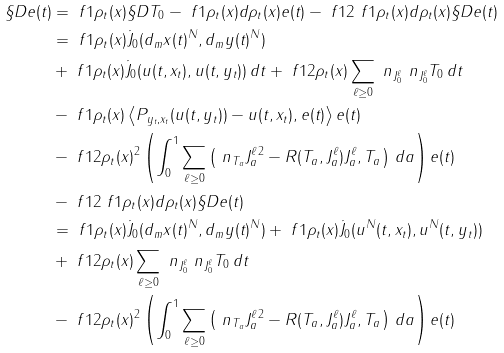<formula> <loc_0><loc_0><loc_500><loc_500>\S D e ( t ) & = \ f 1 { \rho _ { t } ( x ) } \S D T _ { 0 } - \ f 1 { \rho _ { t } ( x ) } d \rho _ { t } ( x ) e ( t ) - \ f 1 2 \ f 1 { \rho _ { t } ( x ) } d \rho _ { t } ( x ) \S D e ( t ) \\ & = \ f 1 { \rho _ { t } ( x ) } \dot { J } _ { 0 } ( d _ { m } x ( t ) ^ { N } , d _ { m } y ( t ) ^ { N } ) \\ & + \ f 1 { \rho _ { t } ( x ) } \dot { J } _ { 0 } ( u ( t , x _ { t } ) , u ( t , y _ { t } ) ) \, d t + \ f 1 { 2 \rho _ { t } ( x ) } \sum _ { \ell \geq 0 } \ n _ { J _ { 0 } ^ { \ell } } \ n _ { J _ { 0 } ^ { \ell } } T _ { 0 } \, d t \\ & - \ f 1 { \rho _ { t } ( x ) } \left \langle P _ { y _ { t } , x _ { t } } ( u ( t , y _ { t } ) ) - u ( t , x _ { t } ) , e ( t ) \right \rangle e ( t ) \\ & - \ f 1 { 2 \rho _ { t } ( x ) ^ { 2 } } \left ( \int _ { 0 } ^ { 1 } \sum _ { \ell \geq 0 } \left ( \| \ n _ { T _ { a } } J _ { a } ^ { \ell } \| ^ { 2 } - R ( T _ { a } , J _ { a } ^ { \ell } ) J _ { a } ^ { \ell } , T _ { a } \right ) \, d a \right ) e ( t ) \\ & - \ f 1 2 \ f 1 { \rho _ { t } ( x ) } d \rho _ { t } ( x ) \S D e ( t ) \\ & = \ f 1 { \rho _ { t } ( x ) } \dot { J } _ { 0 } ( d _ { m } x ( t ) ^ { N } , d _ { m } y ( t ) ^ { N } ) + \ f 1 { \rho _ { t } ( x ) } \dot { J } _ { 0 } ( u ^ { N } ( t , x _ { t } ) , u ^ { N } ( t , y _ { t } ) ) \\ & + \ f 1 { 2 \rho _ { t } ( x ) } \sum _ { \ell \geq 0 } \ n _ { J _ { 0 } ^ { \ell } } \ n _ { J _ { 0 } ^ { \ell } } T _ { 0 } \, d t \\ & - \ f 1 { 2 \rho _ { t } ( x ) ^ { 2 } } \left ( \int _ { 0 } ^ { 1 } \sum _ { \ell \geq 0 } \left ( \| \ n _ { T _ { a } } J _ { a } ^ { \ell } \| ^ { 2 } - R ( T _ { a } , J _ { a } ^ { \ell } ) J _ { a } ^ { \ell } , T _ { a } \right ) \, d a \right ) e ( t )</formula> 